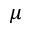Convert formula to latex. <formula><loc_0><loc_0><loc_500><loc_500>\mu</formula> 